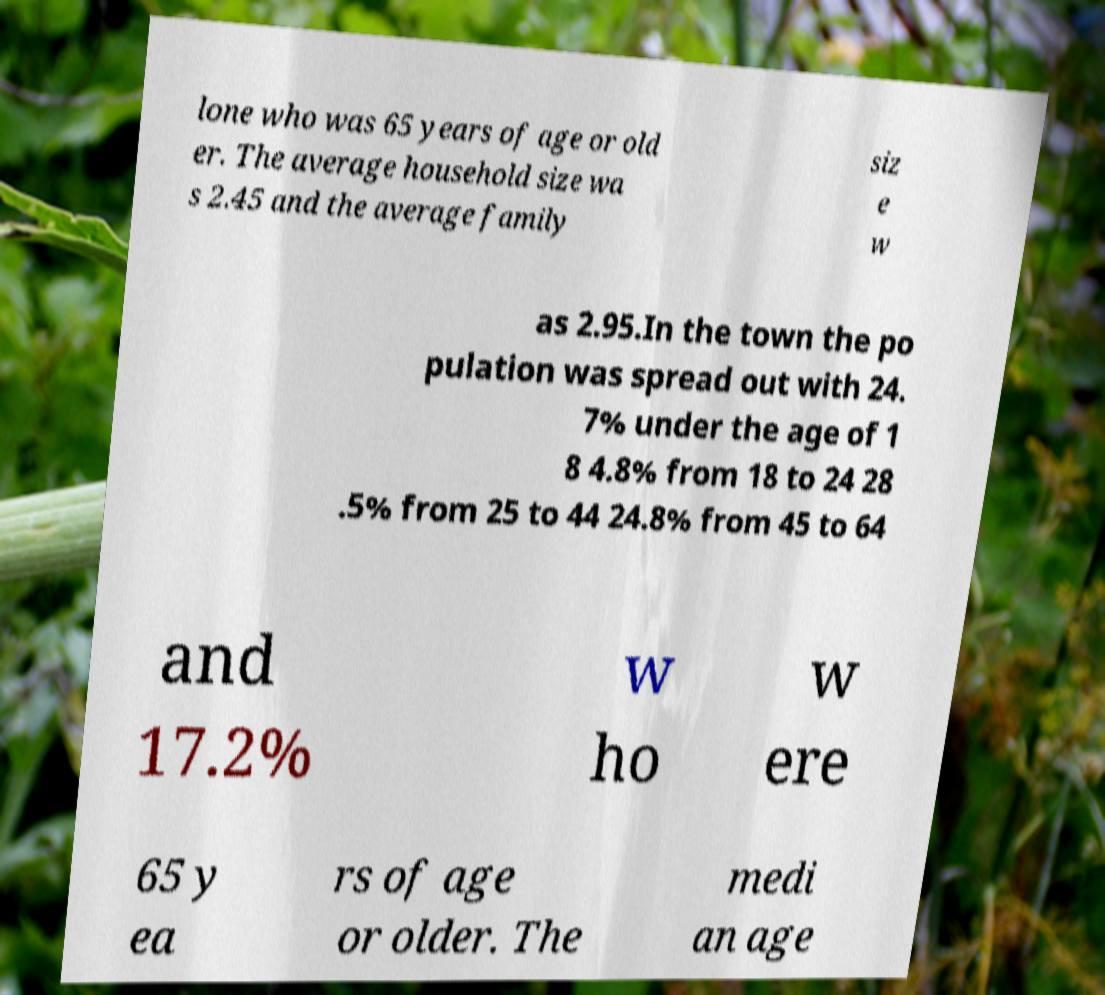Could you assist in decoding the text presented in this image and type it out clearly? lone who was 65 years of age or old er. The average household size wa s 2.45 and the average family siz e w as 2.95.In the town the po pulation was spread out with 24. 7% under the age of 1 8 4.8% from 18 to 24 28 .5% from 25 to 44 24.8% from 45 to 64 and 17.2% w ho w ere 65 y ea rs of age or older. The medi an age 